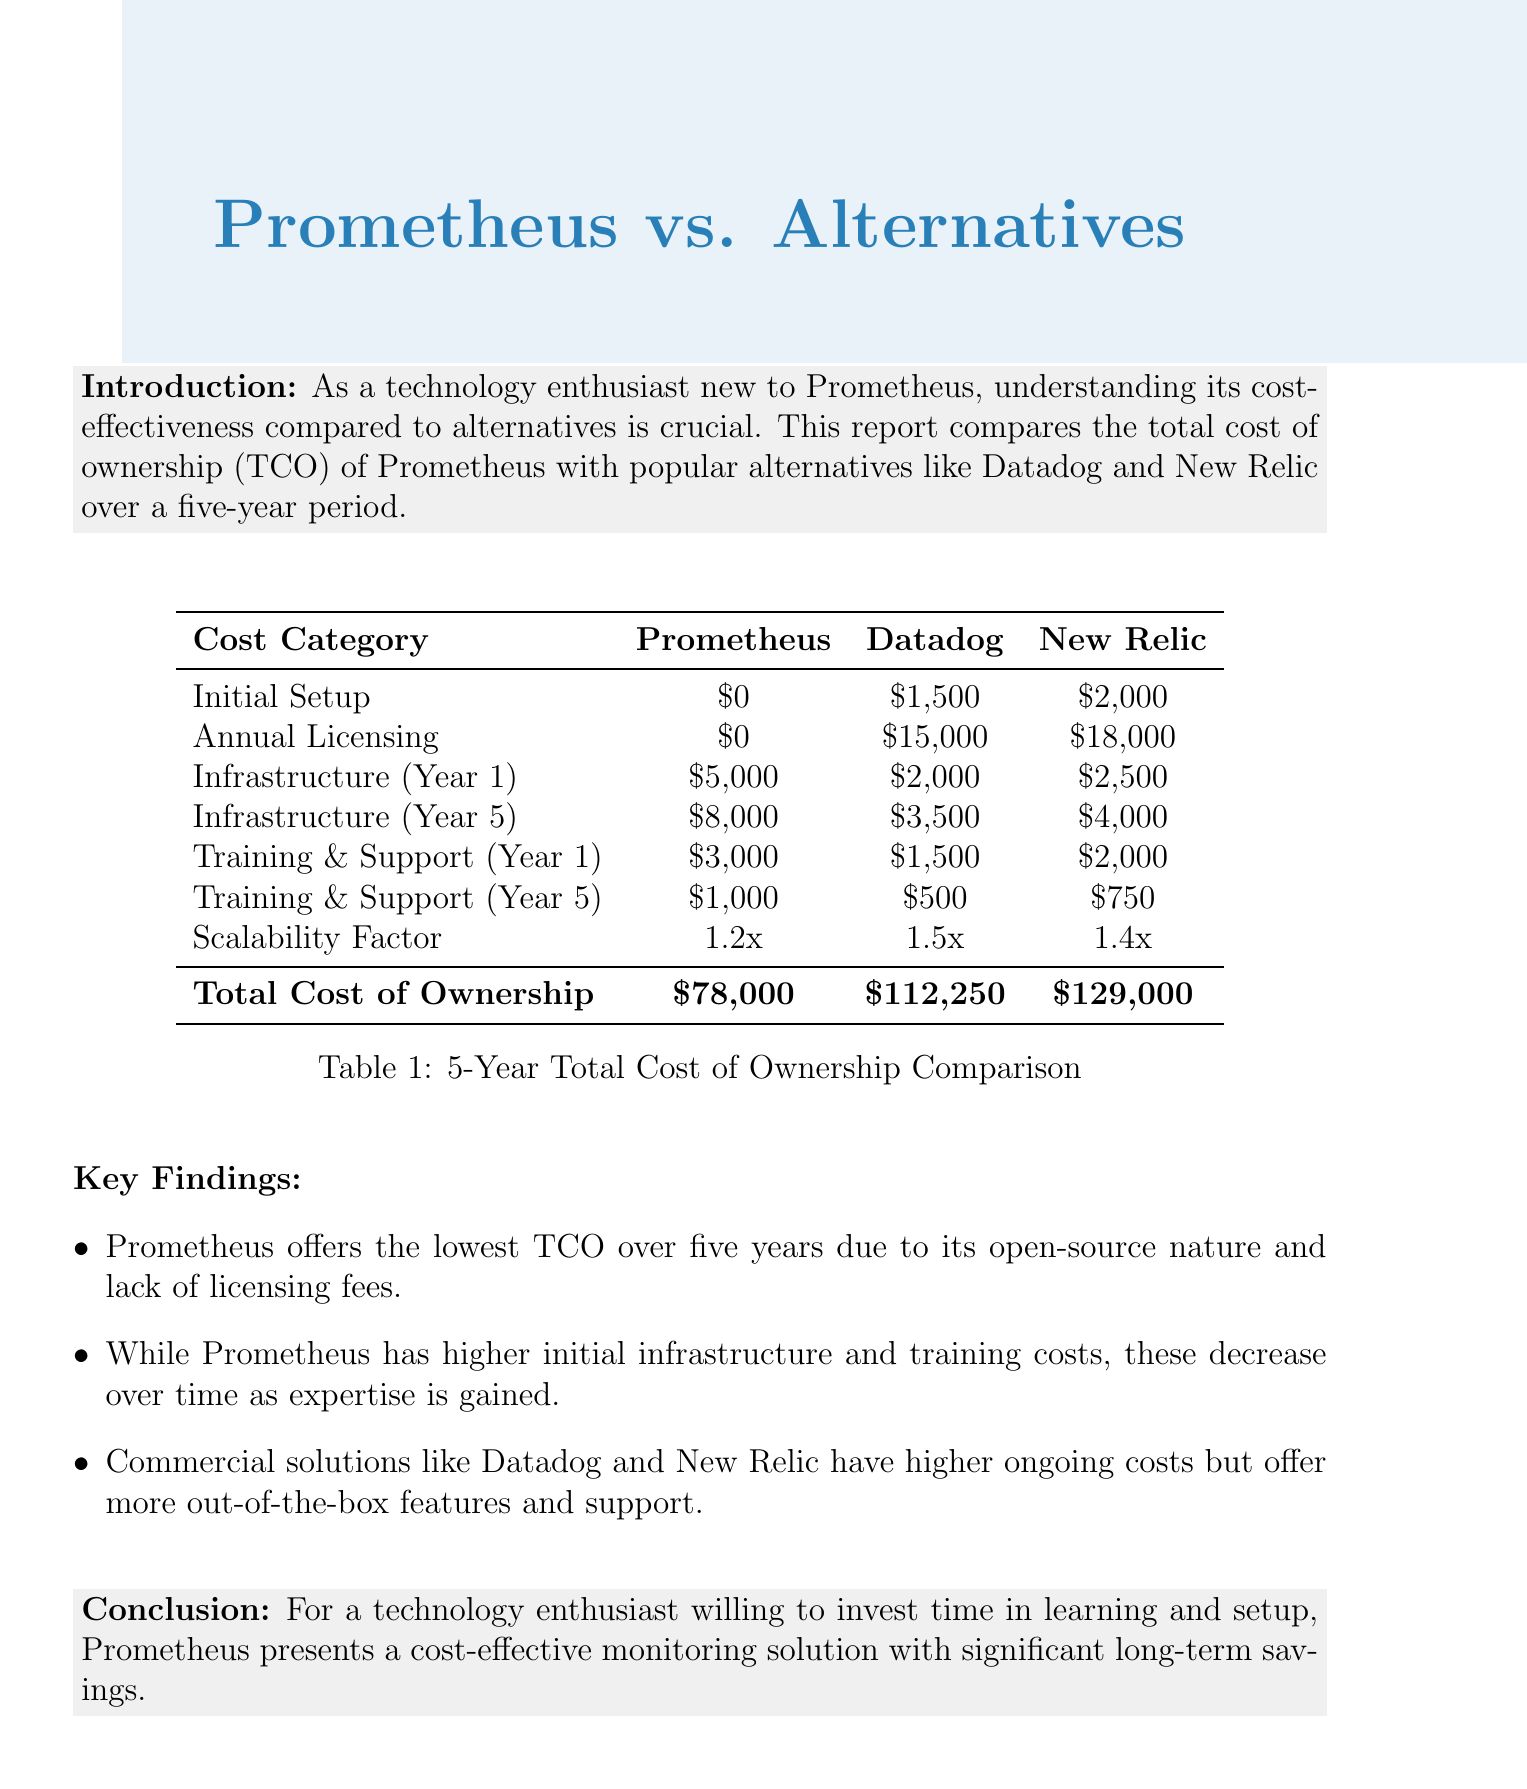what is the initial setup cost for Prometheus? The initial setup cost for Prometheus is mentioned in the initial setup costs section of the document, which states it is $0.
Answer: $0 what is the annual licensing cost of New Relic? The annual licensing cost is specified in the document, showing New Relic's cost is $18,000.
Answer: $18,000 which solution has the highest total cost of ownership? The total cost of ownership is compared in the report, indicating that New Relic has the highest cost of $129,000.
Answer: New Relic what is Prometheus's infrastructure cost in year 5? The infrastructure cost for Prometheus in year 5 is provided in the infrastructure costs section, which is $8,000.
Answer: $8,000 how much does Datadog spend on training and support in year 1? The document lists the training and support costs for Datadog in year 1 as $1,500.
Answer: $1,500 which solution provides the lowest total cost of ownership? The report states that Prometheus offers the lowest total cost of ownership (TCO) over five years.
Answer: Prometheus what is the scalability factor for Datadog? The scalability factor for Datadog is included in the scalability factor section, which indicates it is 1.5x.
Answer: 1.5x what is one key finding regarding Prometheus? The key findings section highlights that Prometheus offers the lowest TCO due to its open-source nature and lack of licensing fees.
Answer: Lowest TCO due to open-source what is the conclusion of the report? The conclusion summarizes that Prometheus is a cost-effective monitoring solution for those willing to invest time.
Answer: Cost-effective monitoring solution 